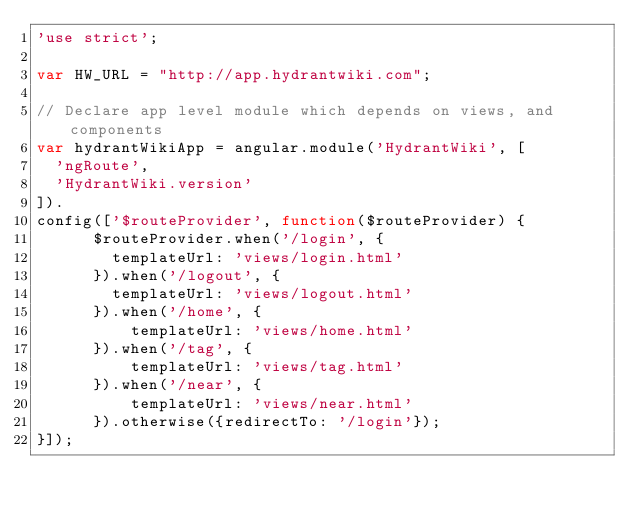Convert code to text. <code><loc_0><loc_0><loc_500><loc_500><_JavaScript_>'use strict';

var HW_URL = "http://app.hydrantwiki.com";

// Declare app level module which depends on views, and components
var hydrantWikiApp = angular.module('HydrantWiki', [
  'ngRoute',
  'HydrantWiki.version'
]).
config(['$routeProvider', function($routeProvider) {
      $routeProvider.when('/login', {
        templateUrl: 'views/login.html'
      }).when('/logout', {
        templateUrl: 'views/logout.html'
      }).when('/home', {
          templateUrl: 'views/home.html'
      }).when('/tag', {
          templateUrl: 'views/tag.html'
      }).when('/near', {
          templateUrl: 'views/near.html'
      }).otherwise({redirectTo: '/login'});
}]);

</code> 